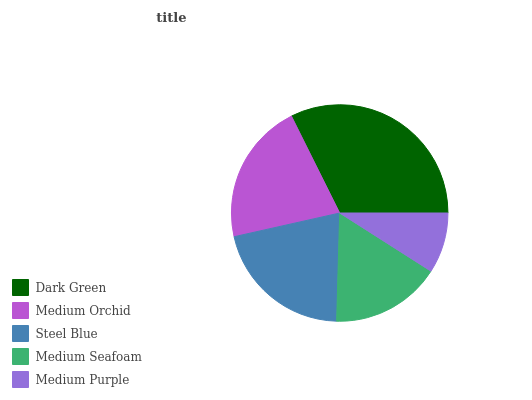Is Medium Purple the minimum?
Answer yes or no. Yes. Is Dark Green the maximum?
Answer yes or no. Yes. Is Medium Orchid the minimum?
Answer yes or no. No. Is Medium Orchid the maximum?
Answer yes or no. No. Is Dark Green greater than Medium Orchid?
Answer yes or no. Yes. Is Medium Orchid less than Dark Green?
Answer yes or no. Yes. Is Medium Orchid greater than Dark Green?
Answer yes or no. No. Is Dark Green less than Medium Orchid?
Answer yes or no. No. Is Steel Blue the high median?
Answer yes or no. Yes. Is Steel Blue the low median?
Answer yes or no. Yes. Is Dark Green the high median?
Answer yes or no. No. Is Medium Purple the low median?
Answer yes or no. No. 